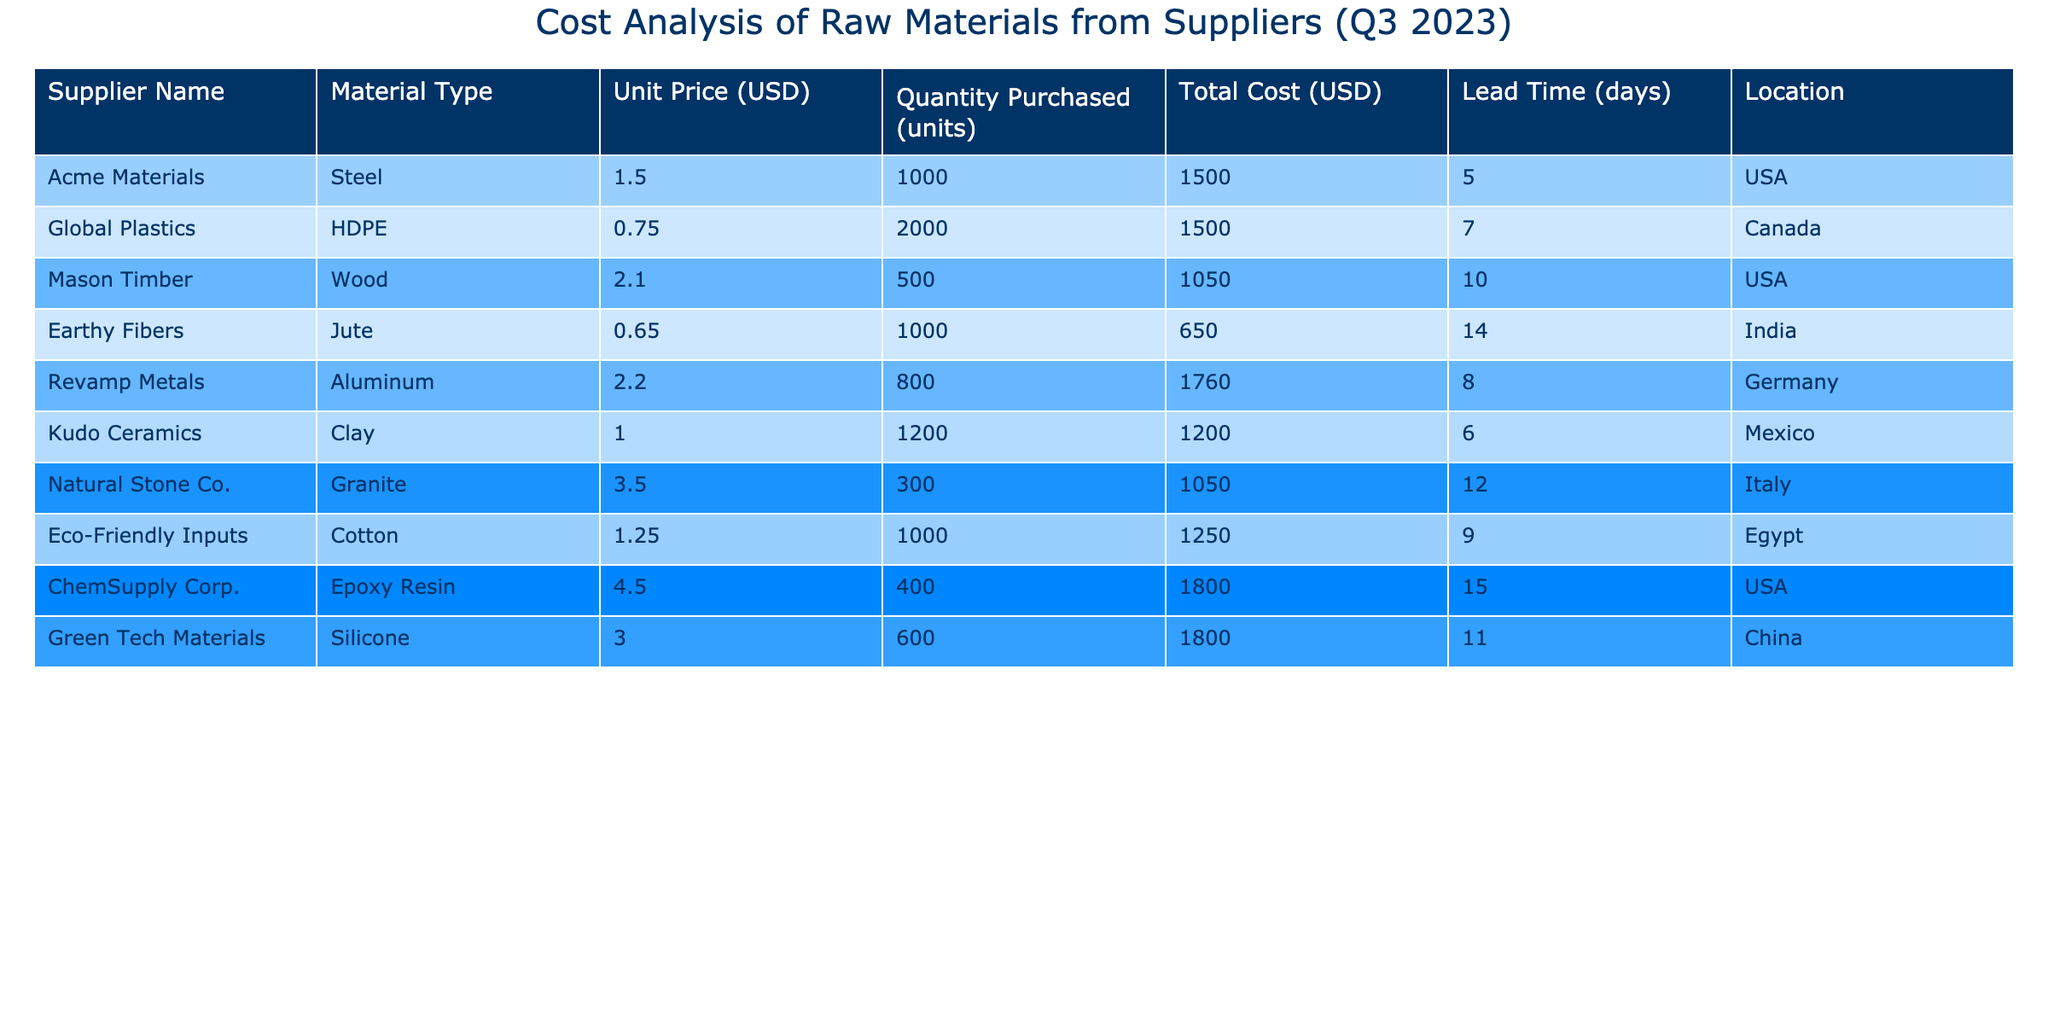What is the total cost of raw materials purchased from Revamp Metals? The total cost for Revamp Metals is specified in the table under the "Total Cost (USD)" column. The value listed is $1760.00.
Answer: $1760.00 Which supplier has the highest unit price for their material? By comparing the "Unit Price (USD)" column for all suppliers, ChemSupply Corp. has the highest unit price at $4.50.
Answer: ChemSupply Corp What is the average unit price of all materials? To find the average unit price, sum all unit prices ($1.50 + $0.75 + $2.10 + $0.65 + $2.20 + $1.00 + $3.50 + $1.25 + $4.50 + $3.00) which equals $19.50, and divide by the number of suppliers (10), resulting in an average unit price of $1.95.
Answer: $1.95 Are there any suppliers that provide materials with a unit price below $1.00? Looking through the "Unit Price (USD)" column, both Earthy Fibers and Global Plastics have unit prices that are below $1.00 at $0.65 and $0.75 respectively, confirming that there are suppliers below this threshold.
Answer: Yes How much more was spent on Aluminum compared to Jute? The total cost for Aluminum is $1760.00 and for Jute is $650.00. The difference is $1760.00 - $650.00 = $1110.00.
Answer: $1110.00 What is the total quantity of materials purchased from suppliers located in the USA? By summing the "Quantity Purchased (units)" for suppliers in the USA (Acme Materials: 1000, Mason Timber: 500, and ChemSupply Corp.: 400), the total quantity is 1000 + 500 + 400 = 1900 units.
Answer: 1900 units Which material type has the longest lead time and how many days is it? The "Lead Time (days)" column shows that ChemSupply Corp.'s Epoxy Resin has the longest lead time of 15 days among all the materials listed.
Answer: 15 days How many suppliers have a lead time of less than 10 days? Reviewing the "Lead Time (days)" column, the suppliers with lead times of less than 10 days are Acme Materials (5), Global Plastics (7), Kudo Ceramics (6), and Revamp Metals (8), resulting in a total of 4 suppliers.
Answer: 4 suppliers What is the total cost incurred for the materials from suppliers in China and India combined? The total cost for Green Tech Materials (China) is $1800.00 and for Earthy Fibers (India) is $650.00. Combining these, the total cost is $1800.00 + $650.00 = $2450.00.
Answer: $2450.00 Is the total cost of Cotton higher or lower than that of Clay? Comparing the total costs, Cotton (Eco-Friendly Inputs) is $1250.00 and Clay (Kudo Ceramics) is $1200.00. Since $1250.00 is greater than $1200.00, the total cost of Cotton is higher.
Answer: Higher 